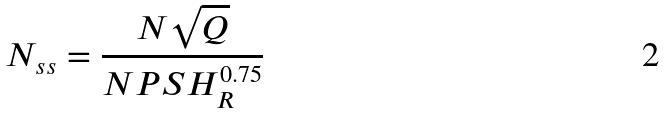Convert formula to latex. <formula><loc_0><loc_0><loc_500><loc_500>N _ { s s } = \frac { N \sqrt { Q } } { N P S H _ { R } ^ { 0 . 7 5 } }</formula> 